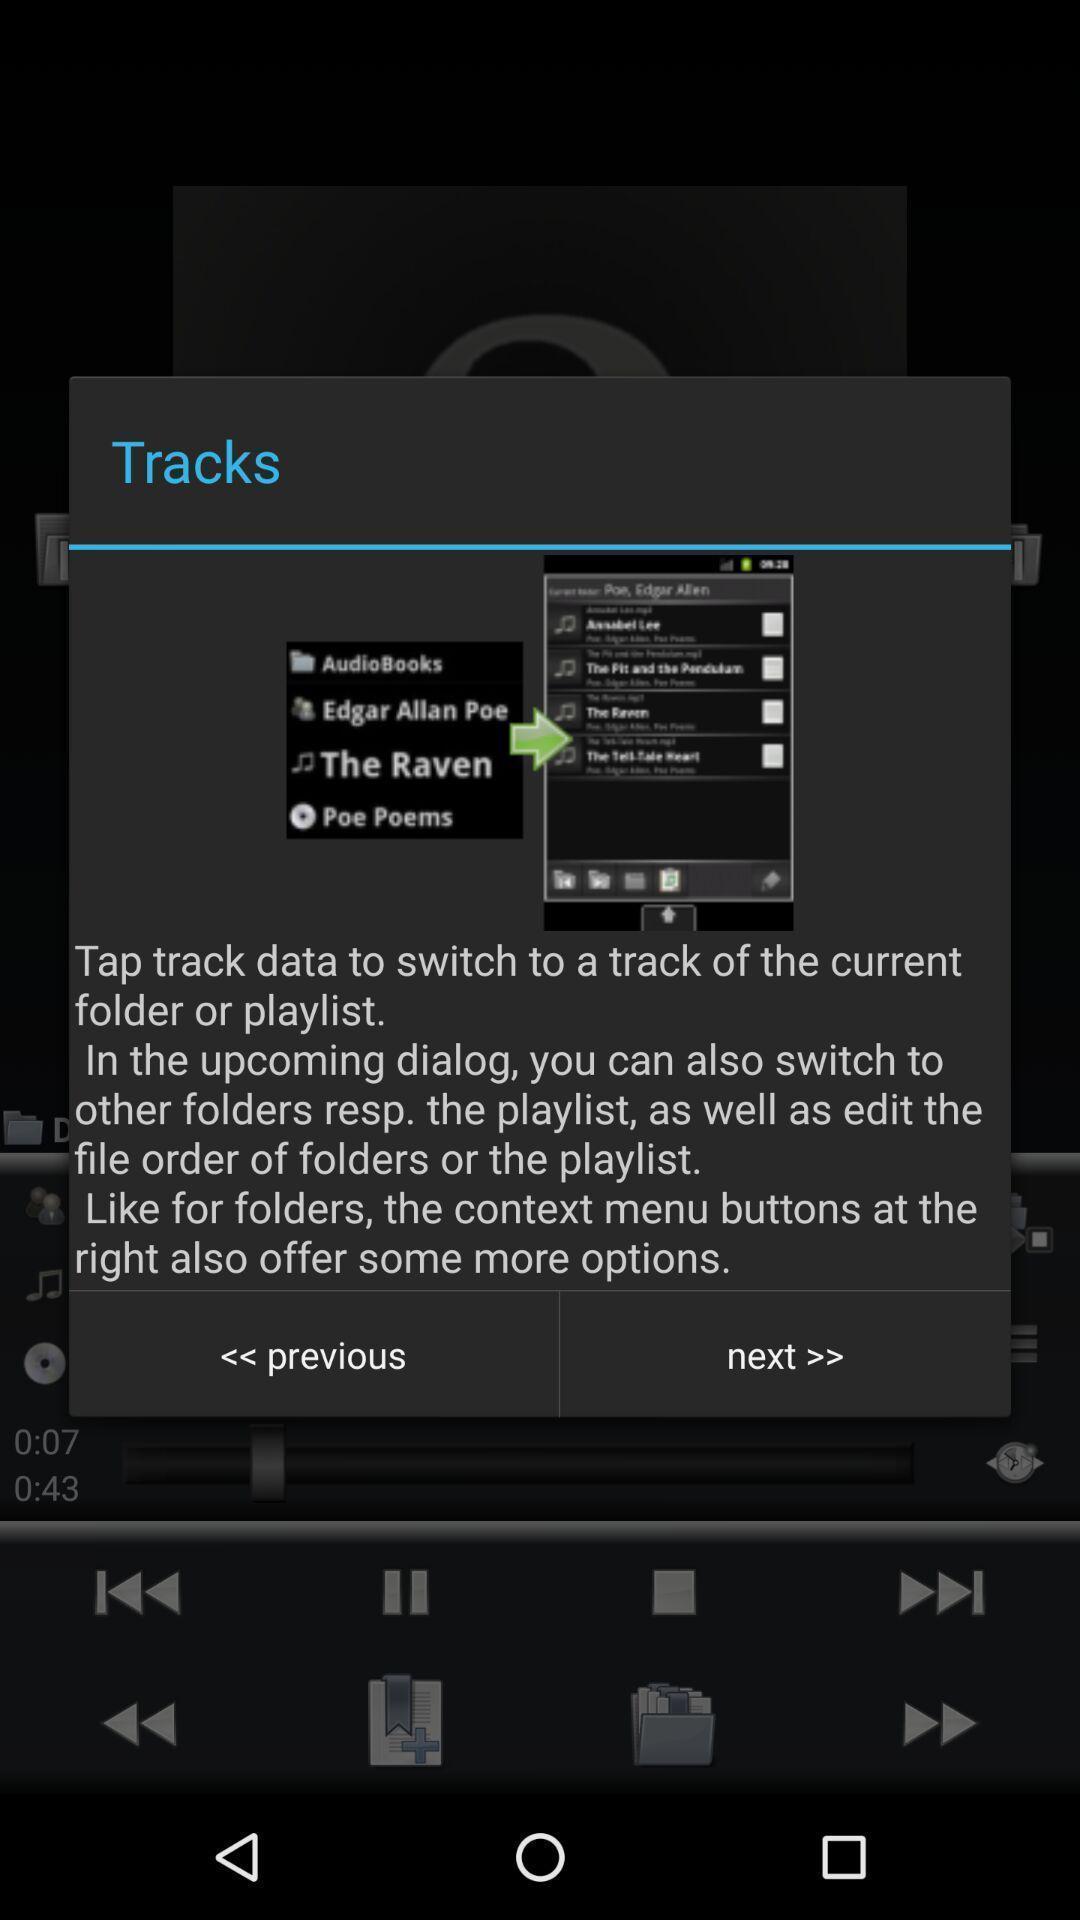What can you discern from this picture? Pop-up showing about track option in a music app. 